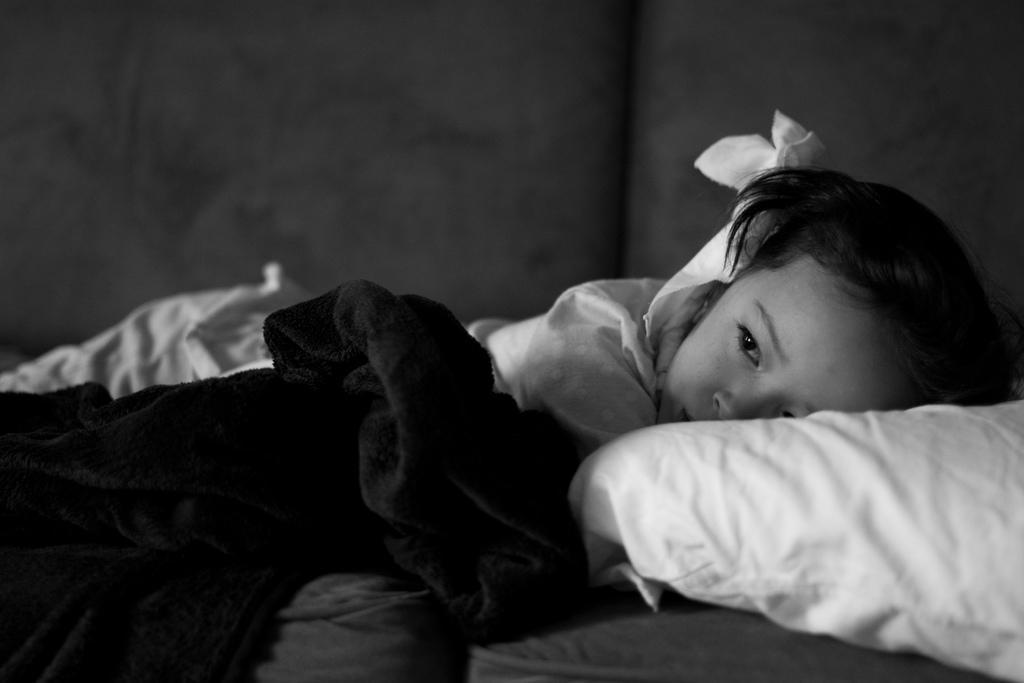In one or two sentences, can you explain what this image depicts? It is a black and white image. In this image there is a girl laying on the bed. There is a pillow on the bed. 